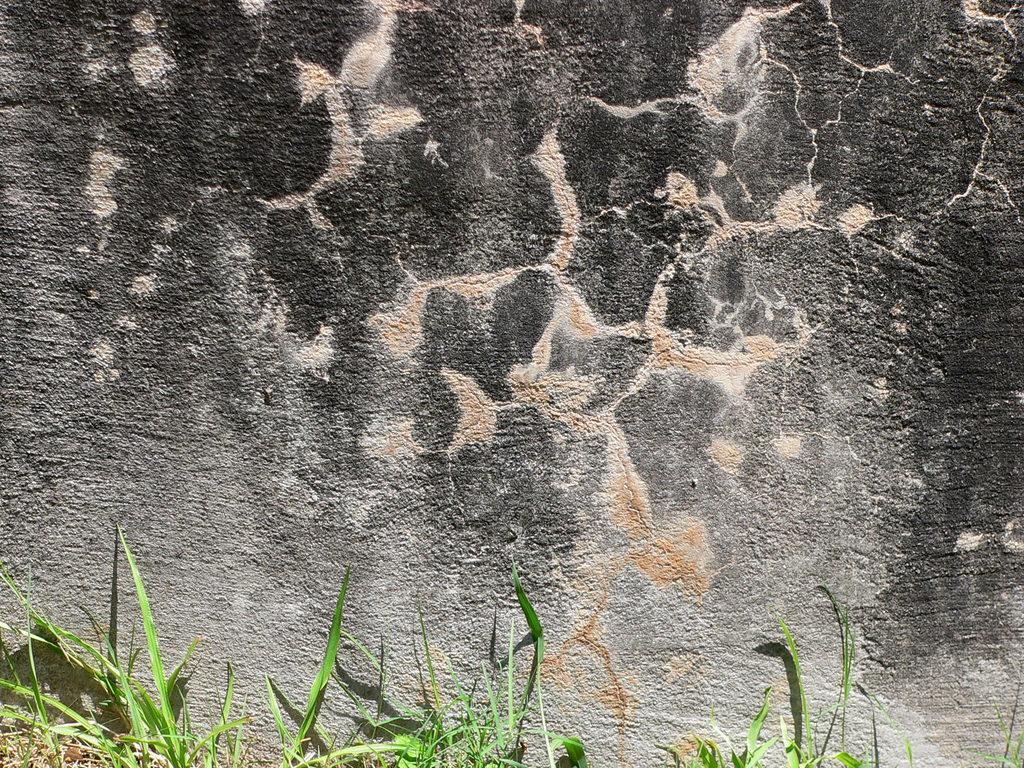Describe this image in one or two sentences. In this picture we can see grass at the bottom, it looks like a rock in the background. 